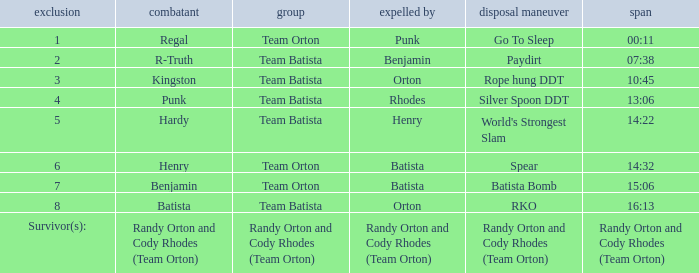What is the Elimination move listed against Regal? Go To Sleep. 